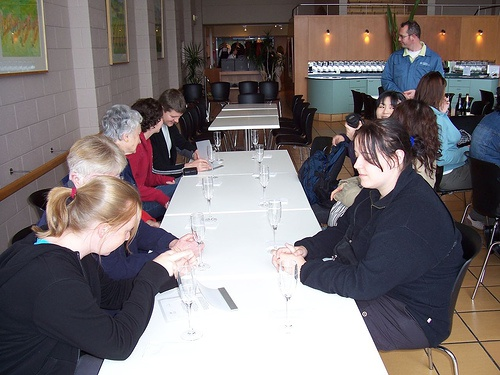Describe the objects in this image and their specific colors. I can see dining table in darkgreen, white, darkgray, and black tones, people in darkgreen, black, gray, and white tones, people in darkgreen, black, lightgray, and gray tones, dining table in darkgreen, lightgray, and darkgray tones, and people in darkgreen, black, and gray tones in this image. 